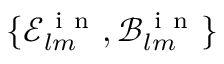<formula> <loc_0><loc_0><loc_500><loc_500>\{ \mathcal { E } _ { l m } ^ { i n } , \mathcal { B } _ { l m } ^ { i n } \}</formula> 